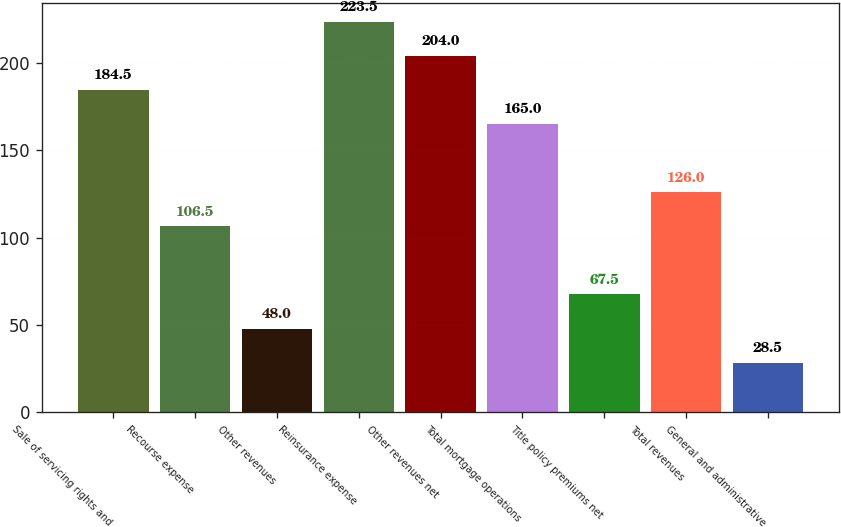Convert chart to OTSL. <chart><loc_0><loc_0><loc_500><loc_500><bar_chart><fcel>Sale of servicing rights and<fcel>Recourse expense<fcel>Other revenues<fcel>Reinsurance expense<fcel>Other revenues net<fcel>Total mortgage operations<fcel>Title policy premiums net<fcel>Total revenues<fcel>General and administrative<nl><fcel>184.5<fcel>106.5<fcel>48<fcel>223.5<fcel>204<fcel>165<fcel>67.5<fcel>126<fcel>28.5<nl></chart> 